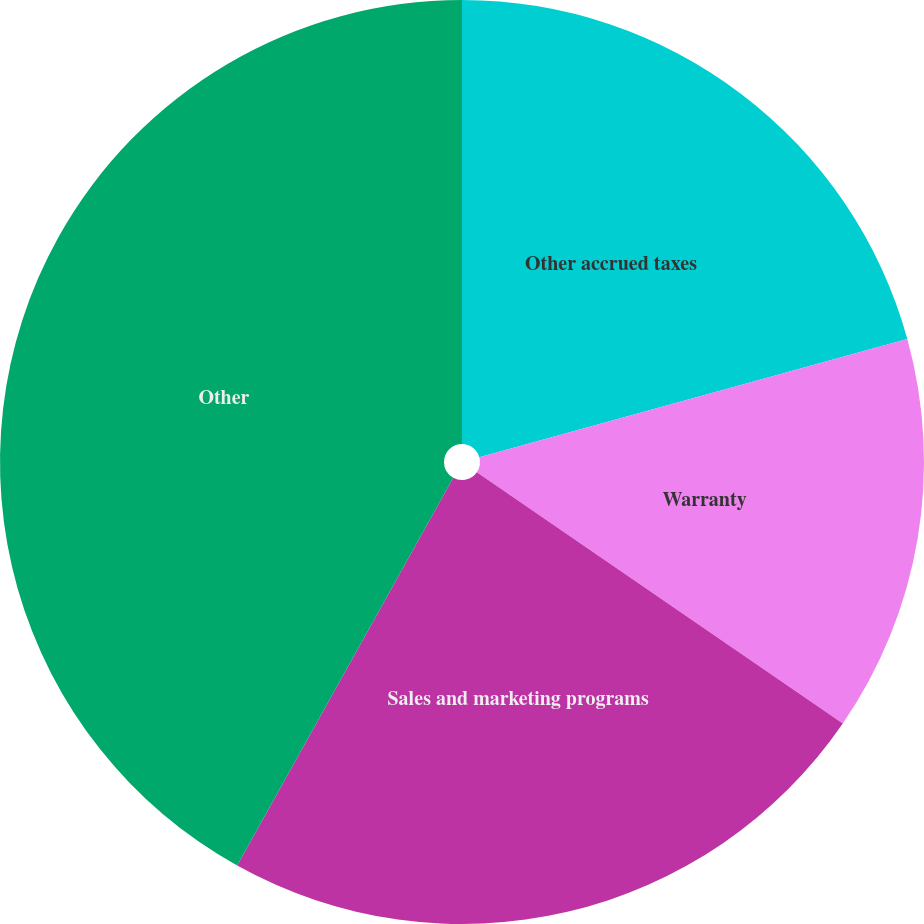Convert chart. <chart><loc_0><loc_0><loc_500><loc_500><pie_chart><fcel>Other accrued taxes<fcel>Warranty<fcel>Sales and marketing programs<fcel>Other<nl><fcel>20.71%<fcel>13.87%<fcel>23.51%<fcel>41.91%<nl></chart> 